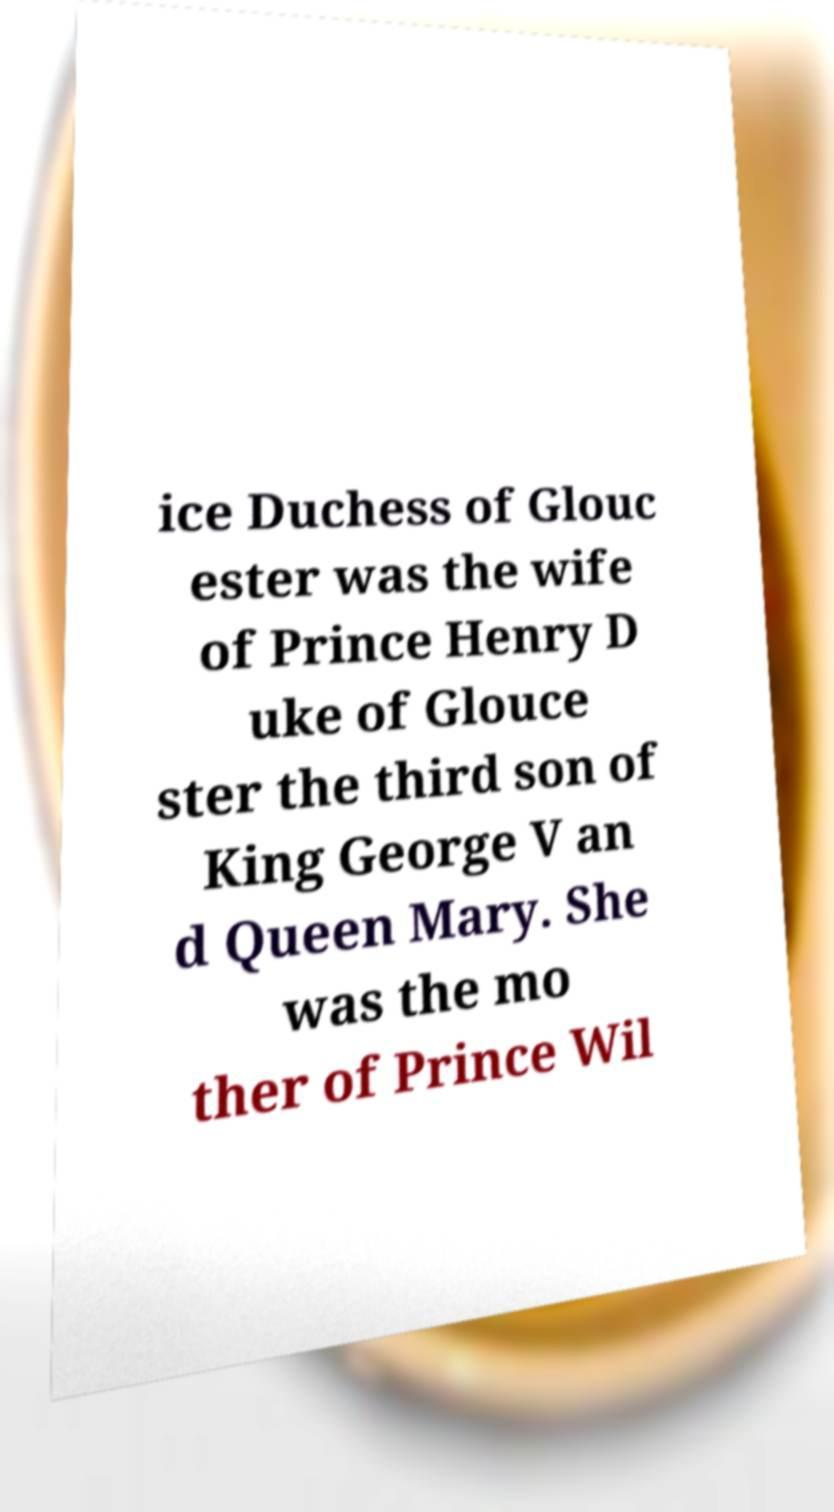What messages or text are displayed in this image? I need them in a readable, typed format. ice Duchess of Glouc ester was the wife of Prince Henry D uke of Glouce ster the third son of King George V an d Queen Mary. She was the mo ther of Prince Wil 